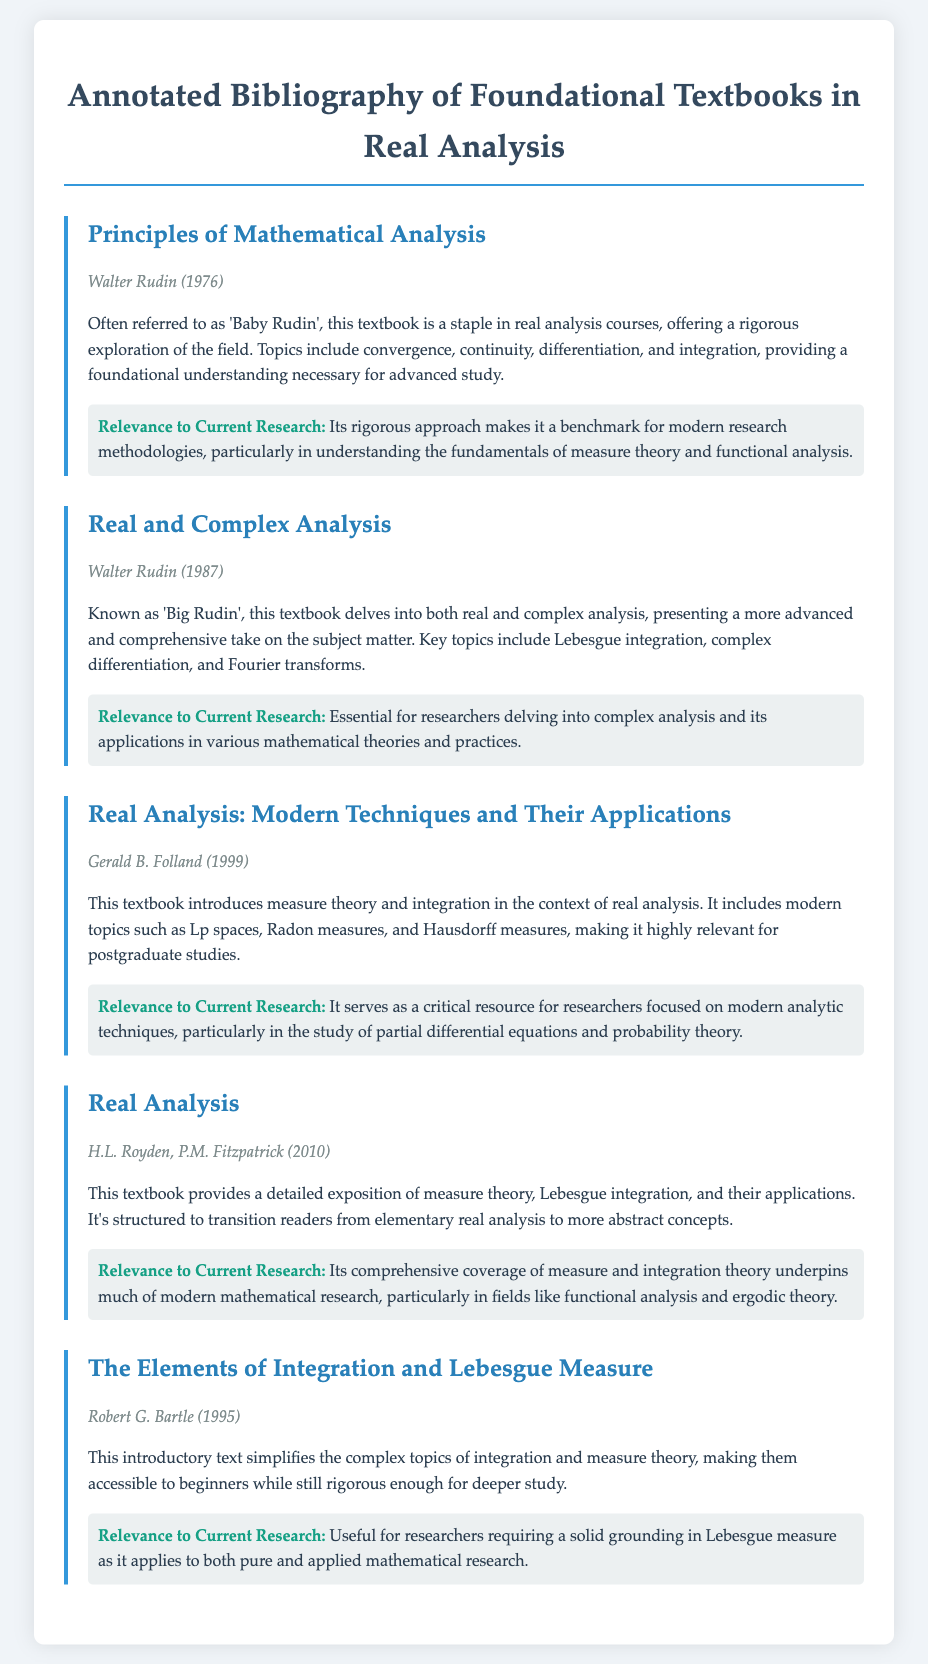What is the title of the first textbook listed? The title of the first textbook is provided in the document under the book section, which is "Principles of Mathematical Analysis".
Answer: Principles of Mathematical Analysis Who is the author of "Real and Complex Analysis"? The author information for "Real and Complex Analysis" is located in the book info section, which states it is by Walter Rudin.
Answer: Walter Rudin In what year was "Real Analysis: Modern Techniques and Their Applications" published? The year for "Real Analysis: Modern Techniques and Their Applications" is mentioned in the book info section as 1999.
Answer: 1999 What is a key topic covered in "The Elements of Integration and Lebesgue Measure"? The document lists various topics covered by the textbooks, noting that "The Elements of Integration and Lebesgue Measure" simplifies the topics of integration and measure theory.
Answer: Integration and measure theory Which textbook is referred to as 'Baby Rudin'? The document specifies that "Principles of Mathematical Analysis" is often referred to as 'Baby Rudin'.
Answer: Principles of Mathematical Analysis What is the relevance of "Real Analysis" to current research? The relevance section of "Real Analysis" states that it underpins much of modern mathematical research, particularly in specific fields.
Answer: Functional analysis and ergodic theory How many textbooks are summarized in the document? By counting the number of book sections in the document, we find that there are five textbooks mentioned.
Answer: Five 